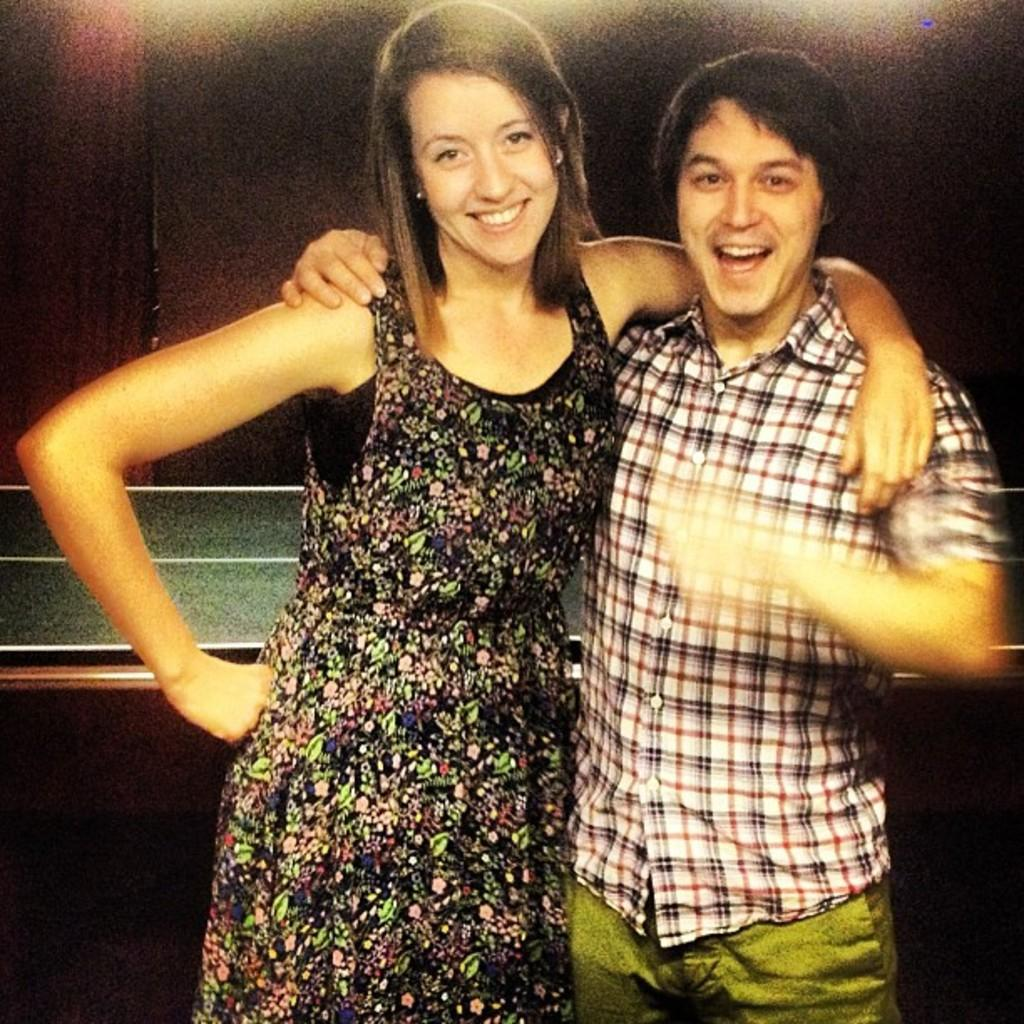How many people are in the image? There are two persons standing in the middle of the image. What can be seen in the background of the image? There is a wall in the background of the image. What type of dress is the person on the left wearing in the image? There is no information about the type of dress the person on the left is wearing, as the facts provided do not mention clothing. 